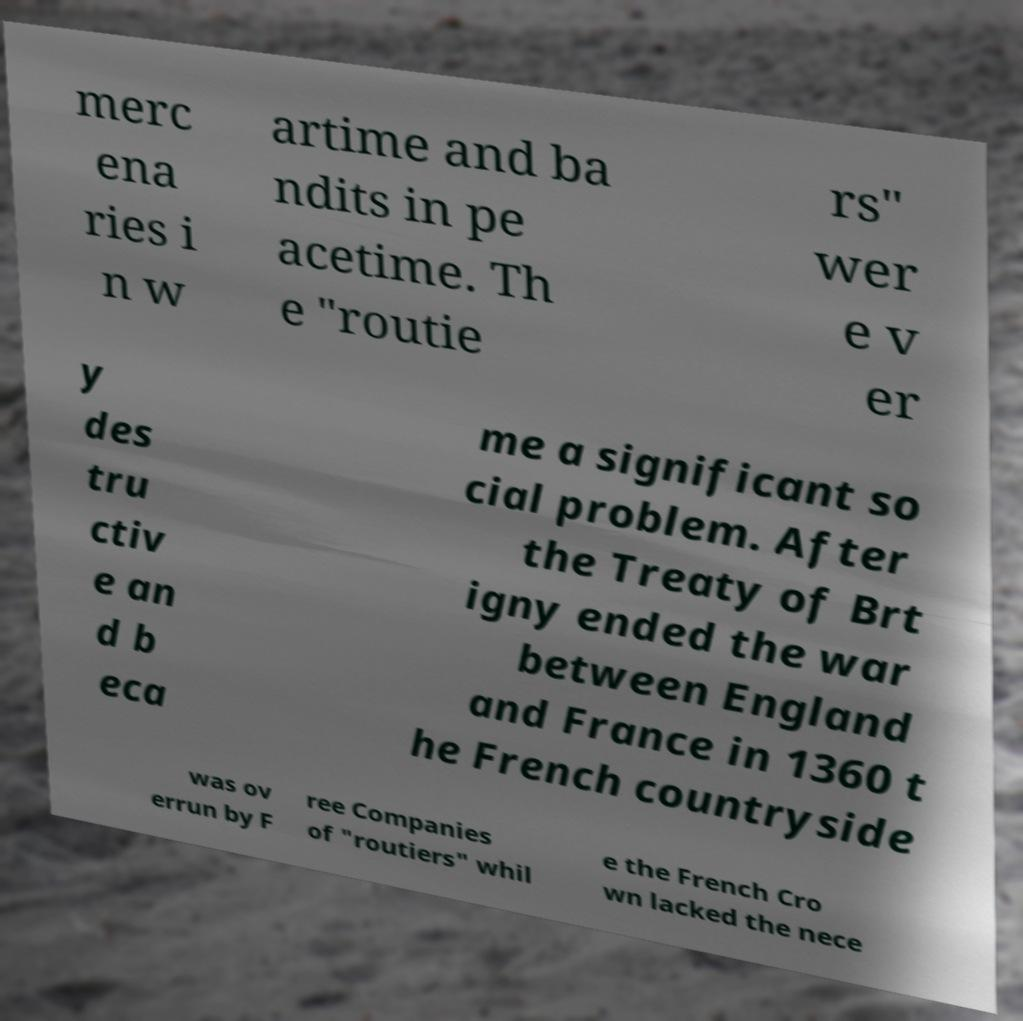Please identify and transcribe the text found in this image. merc ena ries i n w artime and ba ndits in pe acetime. Th e "routie rs" wer e v er y des tru ctiv e an d b eca me a significant so cial problem. After the Treaty of Brt igny ended the war between England and France in 1360 t he French countryside was ov errun by F ree Companies of "routiers" whil e the French Cro wn lacked the nece 